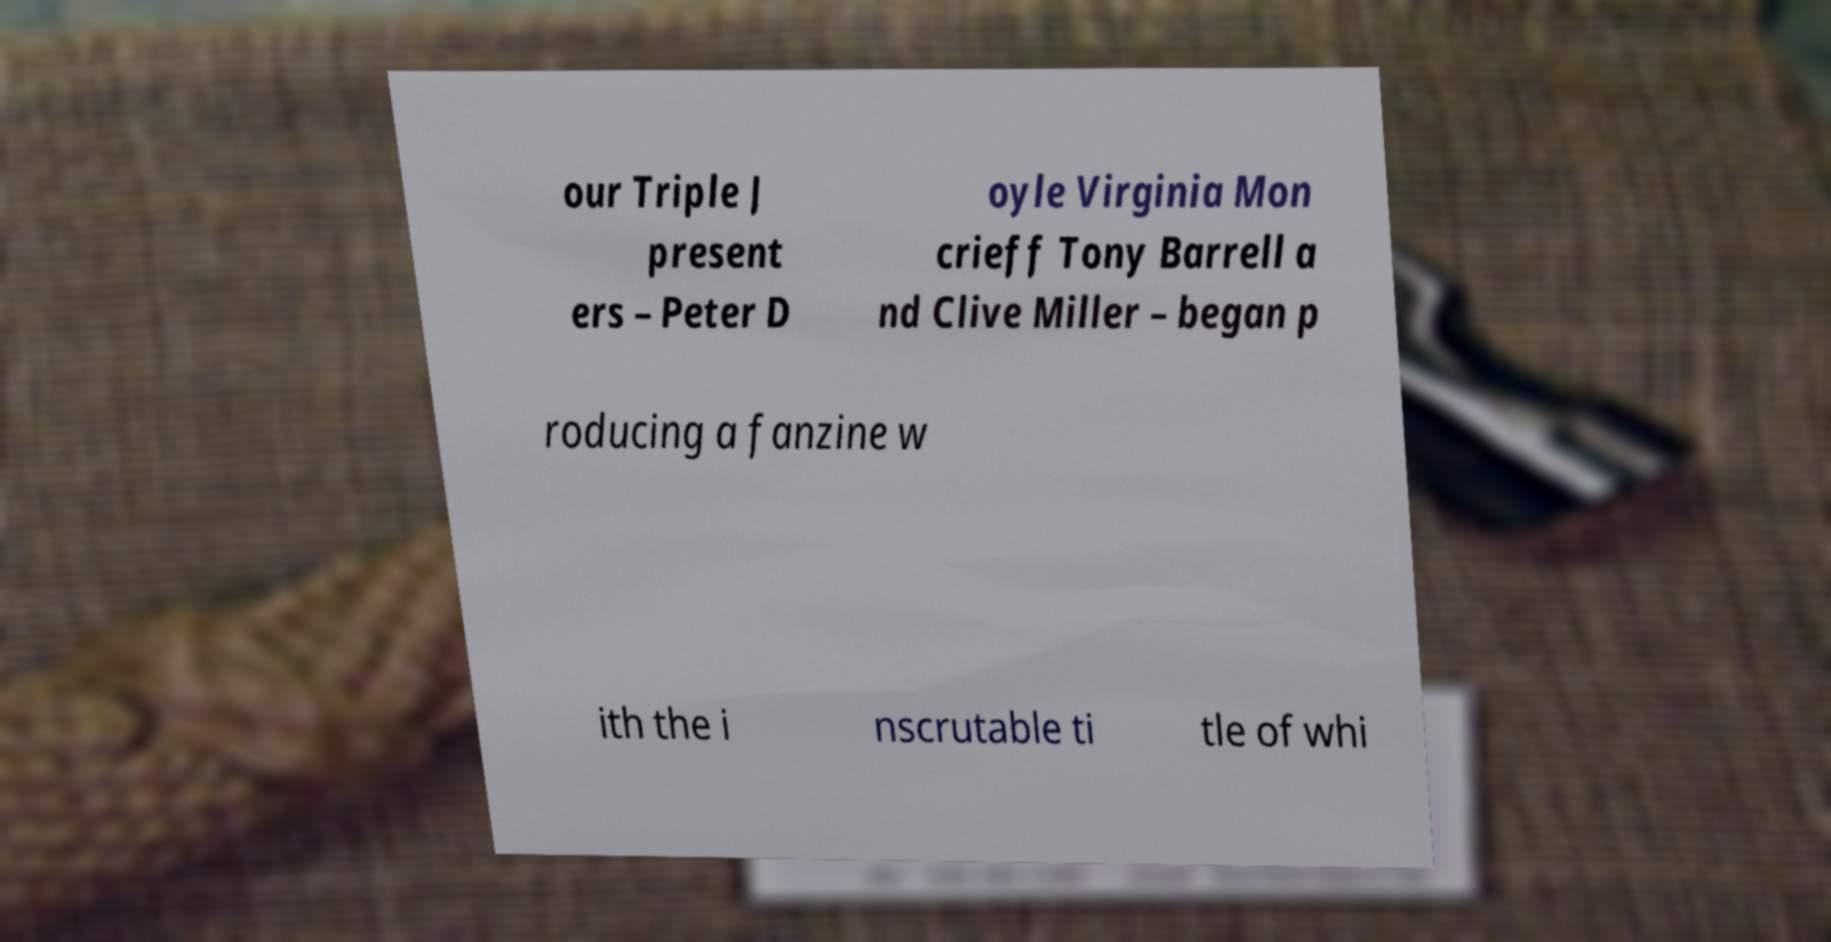Please identify and transcribe the text found in this image. our Triple J present ers – Peter D oyle Virginia Mon crieff Tony Barrell a nd Clive Miller – began p roducing a fanzine w ith the i nscrutable ti tle of whi 